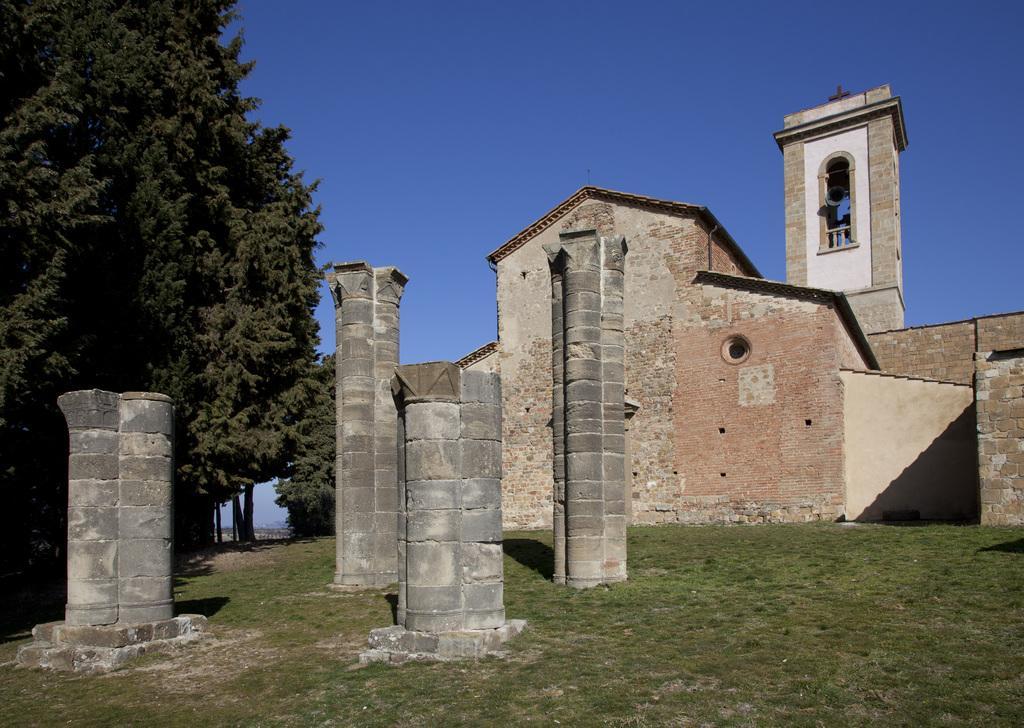How would you summarize this image in a sentence or two? In this image on the right side there is a monastery, in which there is a person, at the top there is the sky, on the left side there are trees, in front of monastery there are pillars visible. 